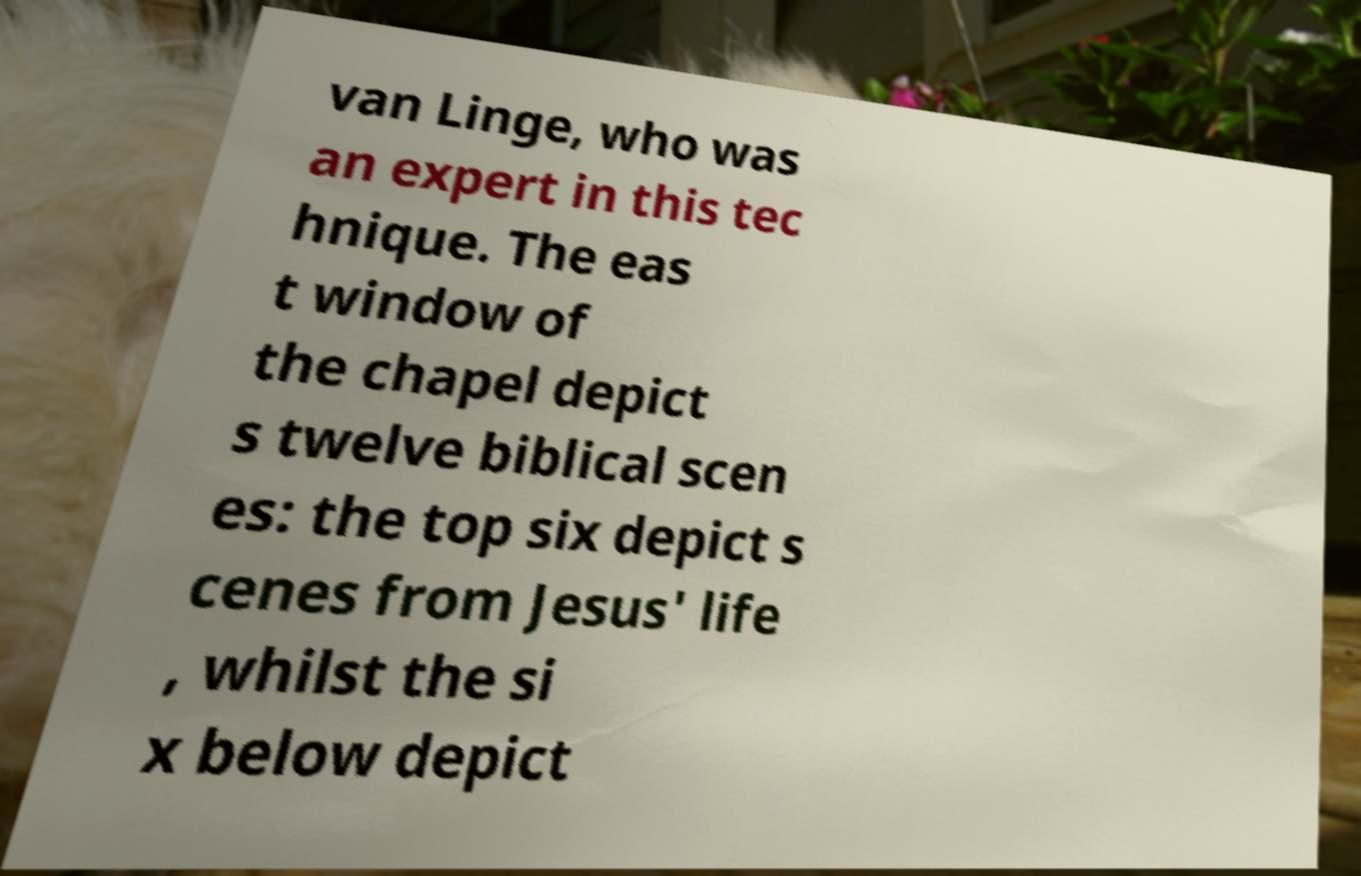Could you extract and type out the text from this image? van Linge, who was an expert in this tec hnique. The eas t window of the chapel depict s twelve biblical scen es: the top six depict s cenes from Jesus' life , whilst the si x below depict 